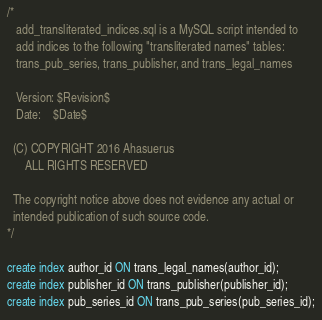Convert code to text. <code><loc_0><loc_0><loc_500><loc_500><_SQL_>/* 
   add_transliterated_indices.sql is a MySQL script intended to
   add indices to the following "transliterated names" tables:
   trans_pub_series, trans_publisher, and trans_legal_names

   Version: $Revision$
   Date:    $Date$

  (C) COPYRIGHT 2016 Ahasuerus
      ALL RIGHTS RESERVED

  The copyright notice above does not evidence any actual or
  intended publication of such source code.
*/

create index author_id ON trans_legal_names(author_id);
create index publisher_id ON trans_publisher(publisher_id);
create index pub_series_id ON trans_pub_series(pub_series_id);
</code> 